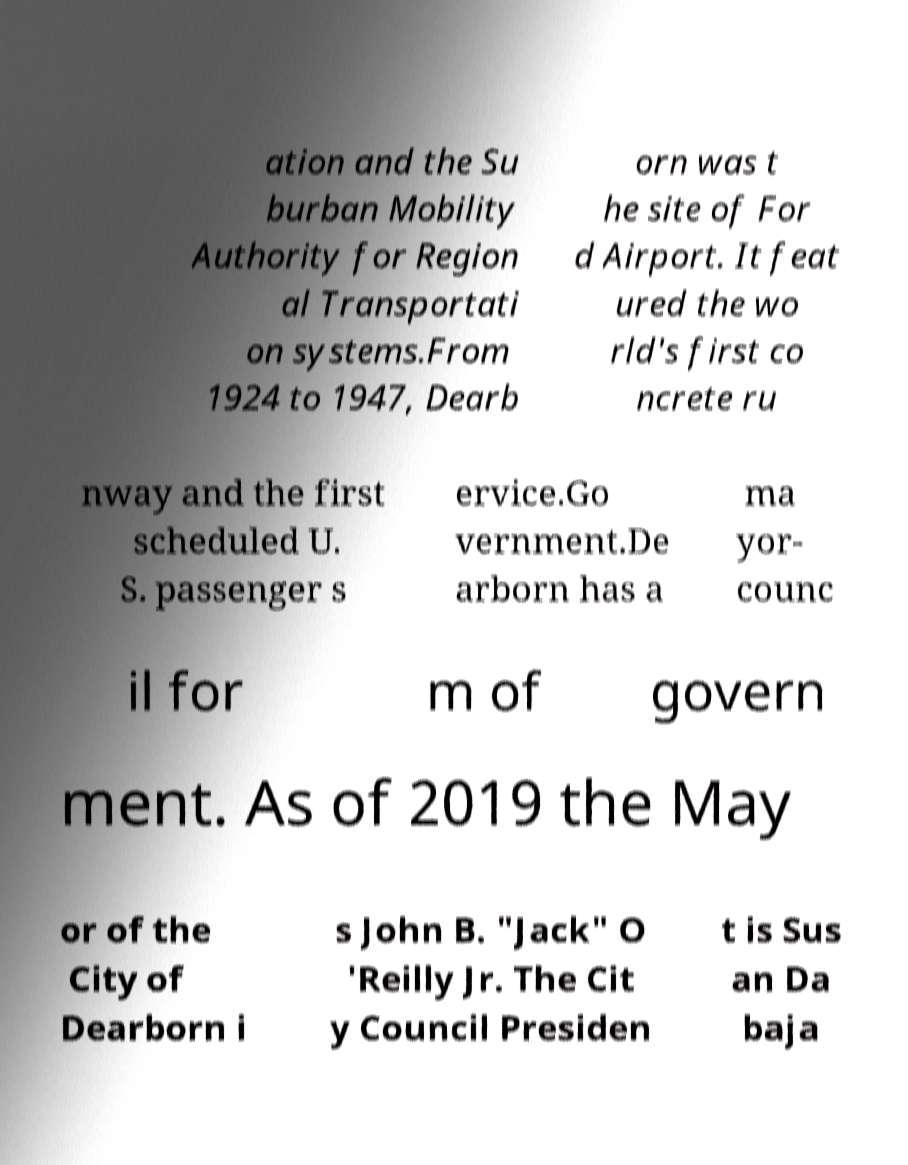What messages or text are displayed in this image? I need them in a readable, typed format. ation and the Su burban Mobility Authority for Region al Transportati on systems.From 1924 to 1947, Dearb orn was t he site of For d Airport. It feat ured the wo rld's first co ncrete ru nway and the first scheduled U. S. passenger s ervice.Go vernment.De arborn has a ma yor- counc il for m of govern ment. As of 2019 the May or of the City of Dearborn i s John B. "Jack" O 'Reilly Jr. The Cit y Council Presiden t is Sus an Da baja 